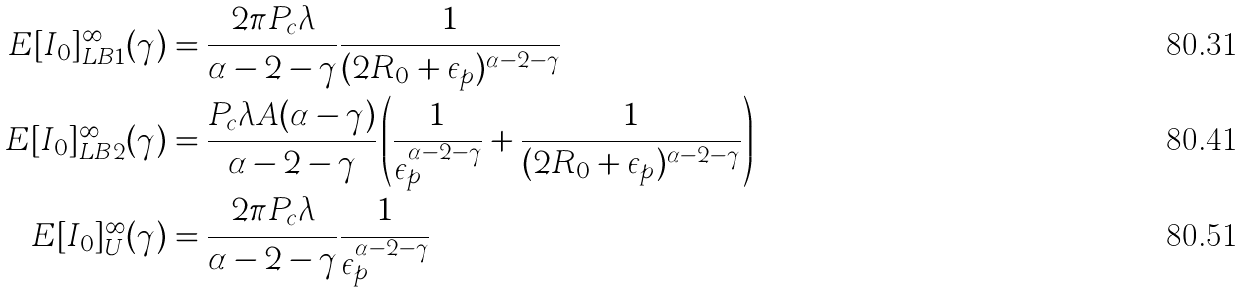Convert formula to latex. <formula><loc_0><loc_0><loc_500><loc_500>E [ I _ { 0 } ] _ { L B 1 } ^ { \infty } ( \gamma ) & = \frac { 2 \pi P _ { c } \lambda } { \alpha - 2 - \gamma } \frac { 1 } { ( 2 R _ { 0 } + \epsilon _ { p } ) ^ { \alpha - 2 - \gamma } } \\ E [ I _ { 0 } ] _ { L B 2 } ^ { \infty } ( \gamma ) & = \frac { P _ { c } \lambda A ( \alpha - \gamma ) } { \alpha - 2 - \gamma } \left ( \frac { 1 } { \epsilon _ { p } ^ { \alpha - 2 - \gamma } } + \frac { 1 } { ( 2 R _ { 0 } + \epsilon _ { p } ) ^ { \alpha - 2 - \gamma } } \right ) \\ E [ I _ { 0 } ] _ { U } ^ { \infty } ( \gamma ) & = \frac { 2 \pi P _ { c } \lambda } { \alpha - 2 - \gamma } \frac { 1 } { \epsilon _ { p } ^ { \alpha - 2 - \gamma } }</formula> 